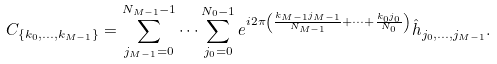Convert formula to latex. <formula><loc_0><loc_0><loc_500><loc_500>C _ { \{ k _ { 0 } , \dots , k _ { M - 1 } \} } = \sum ^ { N _ { M - 1 } - 1 } _ { j _ { M - 1 } = 0 } \dots \sum ^ { N _ { 0 } - 1 } _ { j _ { 0 } = 0 } e ^ { i 2 \pi \left ( \frac { k _ { M - 1 } j _ { M - 1 } } { N _ { M - 1 } } + \dots + \frac { k _ { 0 } j _ { 0 } } { N _ { 0 } } \right ) } \hat { h } _ { j _ { 0 } , \dots , j _ { M - 1 } } .</formula> 